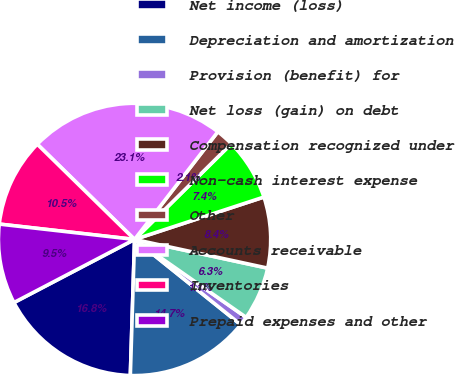Convert chart. <chart><loc_0><loc_0><loc_500><loc_500><pie_chart><fcel>Net income (loss)<fcel>Depreciation and amortization<fcel>Provision (benefit) for<fcel>Net loss (gain) on debt<fcel>Compensation recognized under<fcel>Non-cash interest expense<fcel>Other<fcel>Accounts receivable<fcel>Inventories<fcel>Prepaid expenses and other<nl><fcel>16.83%<fcel>14.73%<fcel>1.06%<fcel>6.32%<fcel>8.42%<fcel>7.37%<fcel>2.11%<fcel>23.14%<fcel>10.53%<fcel>9.47%<nl></chart> 